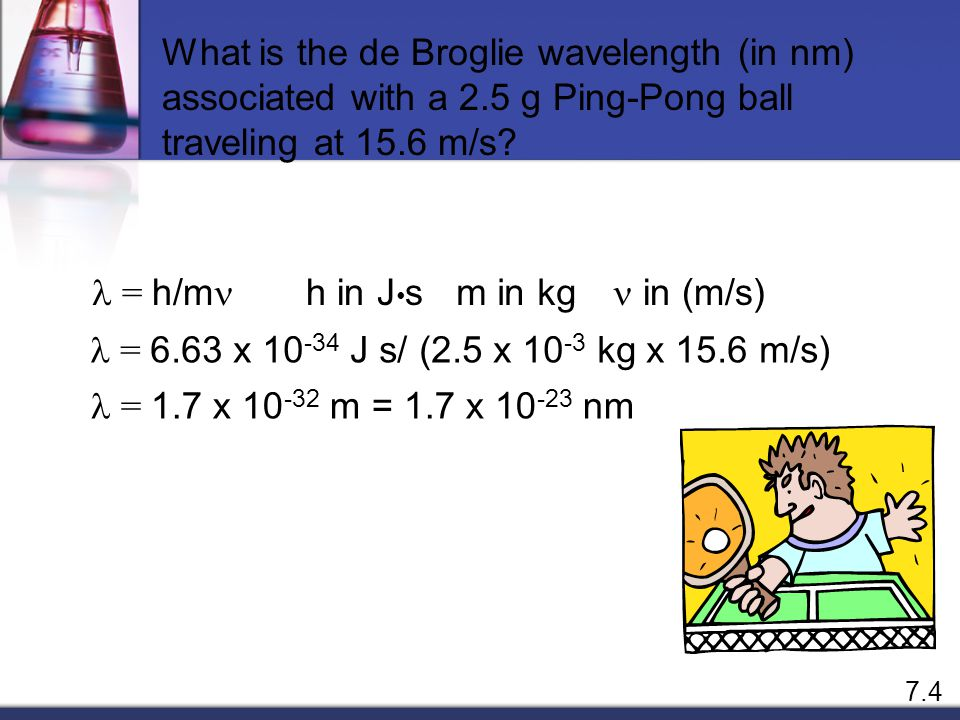How does the addition of scientific equations next to the cartoon enhance the understanding of the image? Including scientific equations next to the cartoon serves a dual purpose. Firstly, it provides a direct educational element, showing the actual mathematical equation (λ = h/mv) used to calculate the de Broglie wavelength, thereby grounding the cartoon in real scientific theory. Secondly, it bridges the gap between theoretical physics and real-world applications, illustrating the practical aspect of these equations in everyday phenomena like playing ping-pong. 